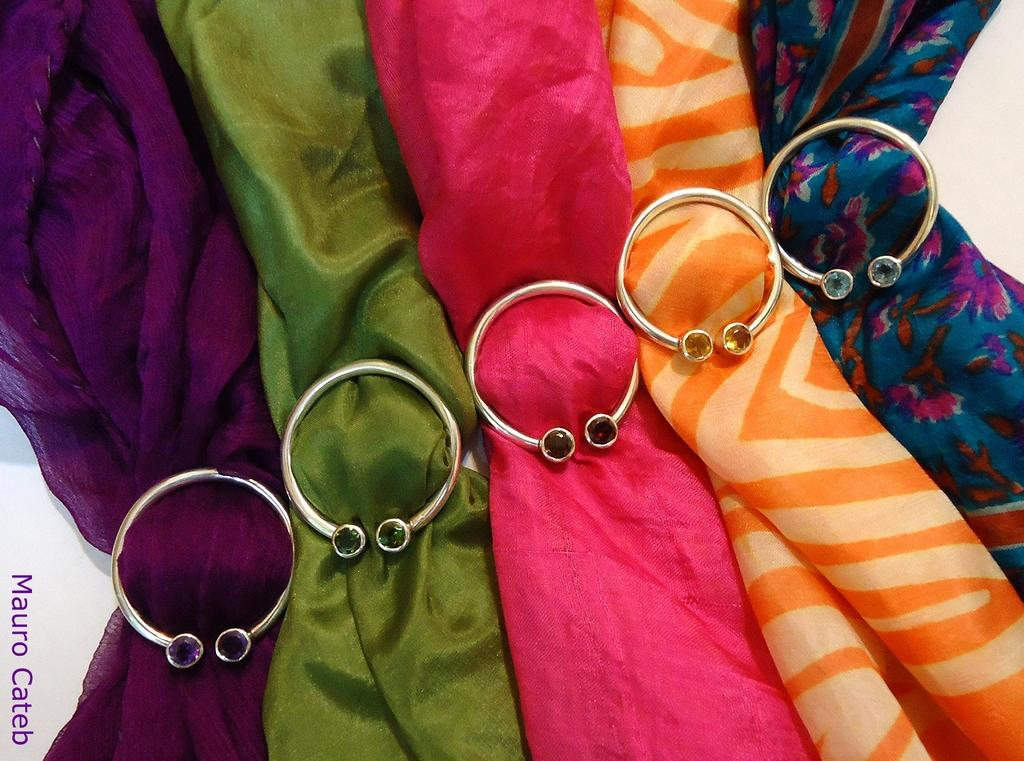What objects are present in the image? There are clothes in the image. Can you describe any unique features of the objects in the image? Yes, there are rings on every cloud in the image. How does the image demonstrate respect for the square? The image does not demonstrate respect for the square, as there is no square present in the image. What type of learning is taking place in the image? There is no learning activity depicted in the image; it features clothes and clouds with rings. 